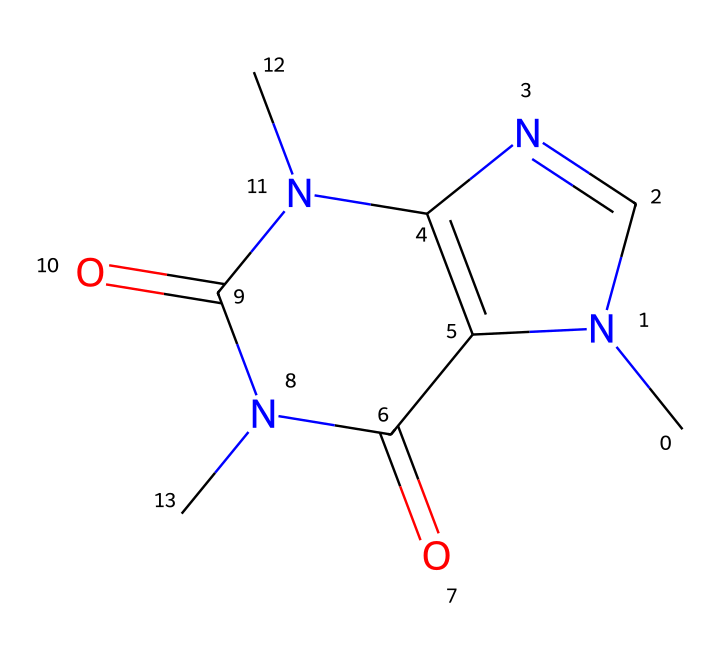What is the molecular formula of caffeine? To determine the molecular formula from the SMILES representation, count the atoms of each element. The provided SMILES shows the presence of 8 carbon (C) atoms, 10 hydrogen (H) atoms, 4 nitrogen (N) atoms, and 2 oxygen (O) atoms. Combining these gives the formula C8H10N4O2.
Answer: C8H10N4O2 How many aromatic rings are present in the caffeine structure? The presence of aromatic rings can be inferred from the rings that contain alternating double bonds, which are a characteristic of aromatic systems. Analyzing the SMILES, there are two fused rings visible that fit this description, indicating there are two aromatic rings.
Answer: 2 What functional groups are present in caffeine? By examining the structure represented in the SMILES, we look for different functional groups. The caffeine molecule includes amide functional groups (-C(=O)N-) and carbonyl groups (C=O). Identifying these gives us the functional groups present.
Answer: amide and carbonyl How does the aromaticity of caffeine affect its solubility in water? Aromatic compounds generally exhibit low water solubility because of non-polar character, but caffeine’s additional nitrogen and oxygen atoms in its structure create polar characteristics, enhancing solubility. Thus, despite its aromaticity, caffeine has good water solubility due to these polar functional groups.
Answer: enhances solubility What type of bonding is primarily responsible for the stability of the aromatic rings in caffeine? Aromatic rings rely on resonance and delocalized electrons to achieve stability, which is evident from the alternating single and double bonds. This resonance within the ring system allows for electron sharing across the structure, making the rings stable.
Answer: resonance What is the role of the nitrogen atoms in caffeine's function as a stimulant? The nitrogen atoms contribute to the overall molecular structure of caffeine, specifically allowing hydrogen bonding with adenosine receptors in the brain. This interaction blocks adenosine’s calming effect, leading to increased alertness.
Answer: blocking adenosine receptors 